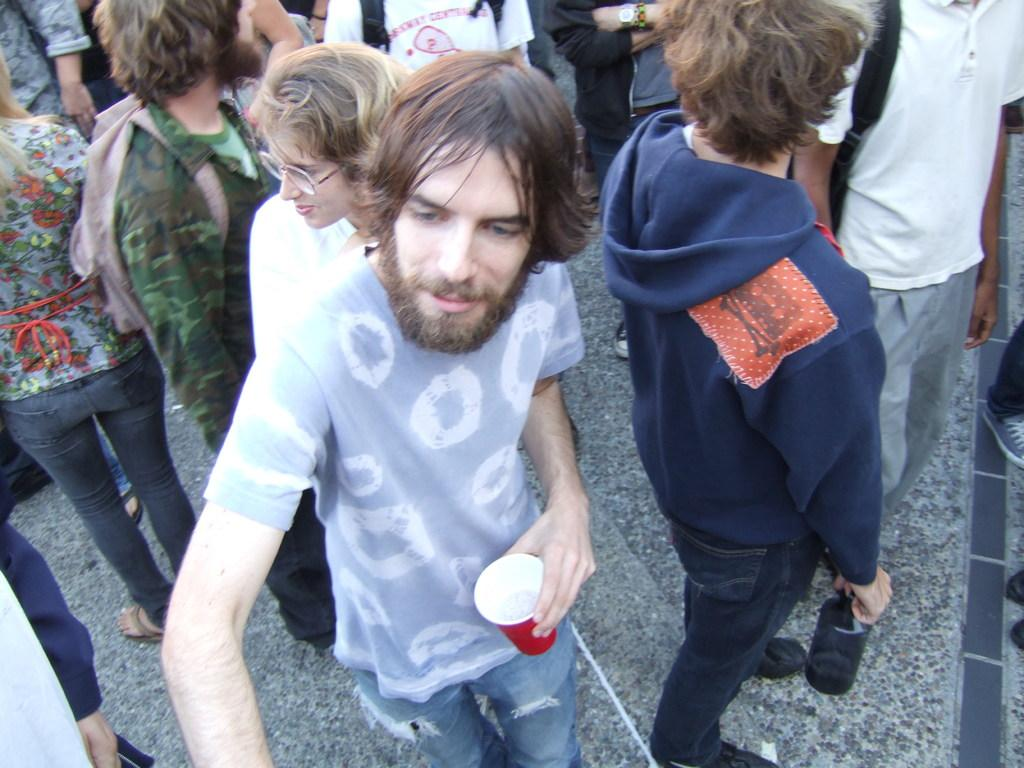How many people are in the image? There are people in the image, but the exact number is not specified. What are the people doing in the image? The people are standing on steps in the image. Can you describe any objects that the people are holding? One of the people is holding a glass in the image. What type of star can be seen in the image? There is no star visible in the image. Can you tell me what kind of apparel the people are wearing in the image? The facts provided do not mention any details about the apparel the people are wearing in the image. 